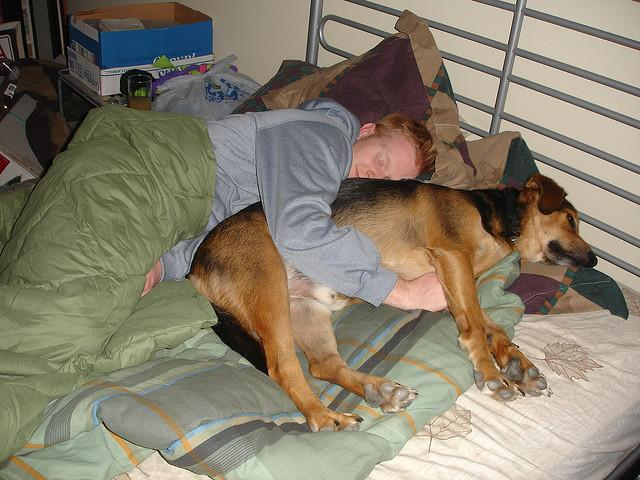What is the owner giving his dog? Please explain your reasoning. hug. He has his hands wrapped around him and this is how people give hugs. 